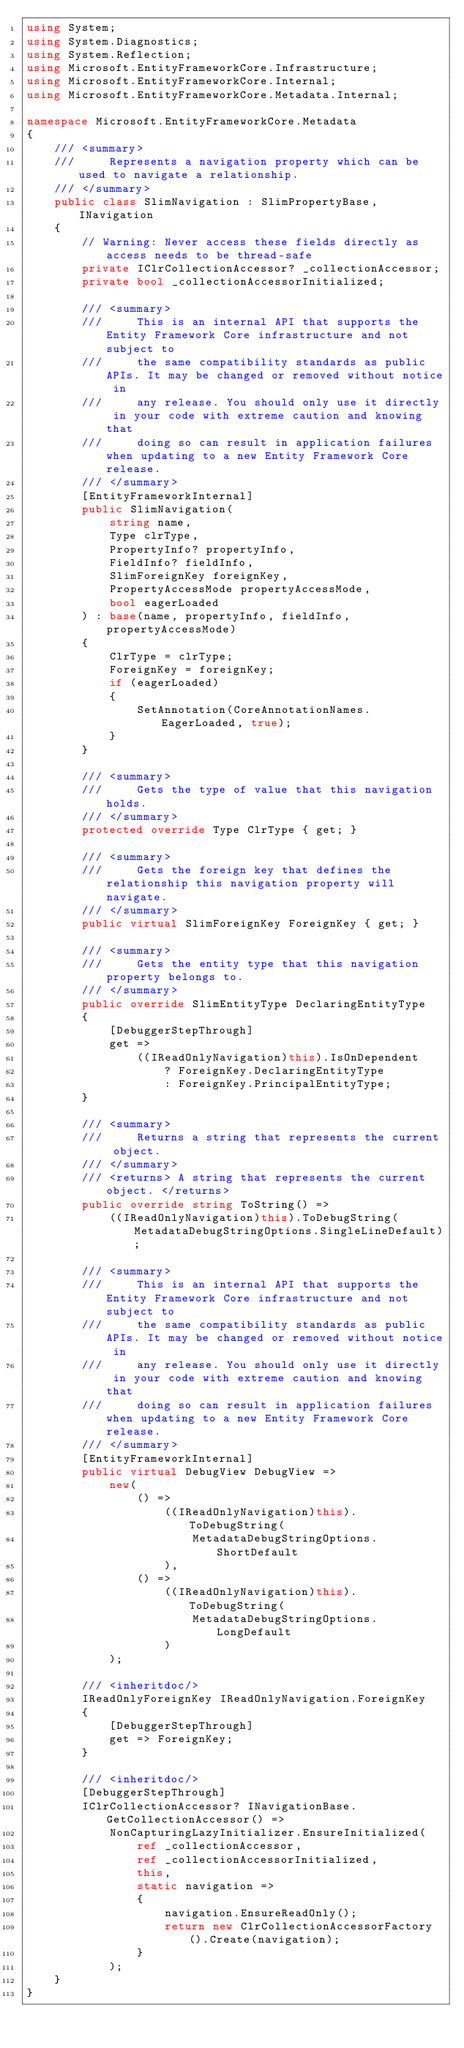Convert code to text. <code><loc_0><loc_0><loc_500><loc_500><_C#_>using System;
using System.Diagnostics;
using System.Reflection;
using Microsoft.EntityFrameworkCore.Infrastructure;
using Microsoft.EntityFrameworkCore.Internal;
using Microsoft.EntityFrameworkCore.Metadata.Internal;

namespace Microsoft.EntityFrameworkCore.Metadata
{
    /// <summary>
    ///     Represents a navigation property which can be used to navigate a relationship.
    /// </summary>
    public class SlimNavigation : SlimPropertyBase, INavigation
    {
        // Warning: Never access these fields directly as access needs to be thread-safe
        private IClrCollectionAccessor? _collectionAccessor;
        private bool _collectionAccessorInitialized;

        /// <summary>
        ///     This is an internal API that supports the Entity Framework Core infrastructure and not subject to
        ///     the same compatibility standards as public APIs. It may be changed or removed without notice in
        ///     any release. You should only use it directly in your code with extreme caution and knowing that
        ///     doing so can result in application failures when updating to a new Entity Framework Core release.
        /// </summary>
        [EntityFrameworkInternal]
        public SlimNavigation(
            string name,
            Type clrType,
            PropertyInfo? propertyInfo,
            FieldInfo? fieldInfo,
            SlimForeignKey foreignKey,
            PropertyAccessMode propertyAccessMode,
            bool eagerLoaded
        ) : base(name, propertyInfo, fieldInfo, propertyAccessMode)
        {
            ClrType = clrType;
            ForeignKey = foreignKey;
            if (eagerLoaded)
            {
                SetAnnotation(CoreAnnotationNames.EagerLoaded, true);
            }
        }

        /// <summary>
        ///     Gets the type of value that this navigation holds.
        /// </summary>
        protected override Type ClrType { get; }

        /// <summary>
        ///     Gets the foreign key that defines the relationship this navigation property will navigate.
        /// </summary>
        public virtual SlimForeignKey ForeignKey { get; }

        /// <summary>
        ///     Gets the entity type that this navigation property belongs to.
        /// </summary>
        public override SlimEntityType DeclaringEntityType
        {
            [DebuggerStepThrough]
            get =>
                ((IReadOnlyNavigation)this).IsOnDependent
                    ? ForeignKey.DeclaringEntityType
                    : ForeignKey.PrincipalEntityType;
        }

        /// <summary>
        ///     Returns a string that represents the current object.
        /// </summary>
        /// <returns> A string that represents the current object. </returns>
        public override string ToString() =>
            ((IReadOnlyNavigation)this).ToDebugString(MetadataDebugStringOptions.SingleLineDefault);

        /// <summary>
        ///     This is an internal API that supports the Entity Framework Core infrastructure and not subject to
        ///     the same compatibility standards as public APIs. It may be changed or removed without notice in
        ///     any release. You should only use it directly in your code with extreme caution and knowing that
        ///     doing so can result in application failures when updating to a new Entity Framework Core release.
        /// </summary>
        [EntityFrameworkInternal]
        public virtual DebugView DebugView =>
            new(
                () =>
                    ((IReadOnlyNavigation)this).ToDebugString(
                        MetadataDebugStringOptions.ShortDefault
                    ),
                () =>
                    ((IReadOnlyNavigation)this).ToDebugString(
                        MetadataDebugStringOptions.LongDefault
                    )
            );

        /// <inheritdoc/>
        IReadOnlyForeignKey IReadOnlyNavigation.ForeignKey
        {
            [DebuggerStepThrough]
            get => ForeignKey;
        }

        /// <inheritdoc/>
        [DebuggerStepThrough]
        IClrCollectionAccessor? INavigationBase.GetCollectionAccessor() =>
            NonCapturingLazyInitializer.EnsureInitialized(
                ref _collectionAccessor,
                ref _collectionAccessorInitialized,
                this,
                static navigation =>
                {
                    navigation.EnsureReadOnly();
                    return new ClrCollectionAccessorFactory().Create(navigation);
                }
            );
    }
}
</code> 